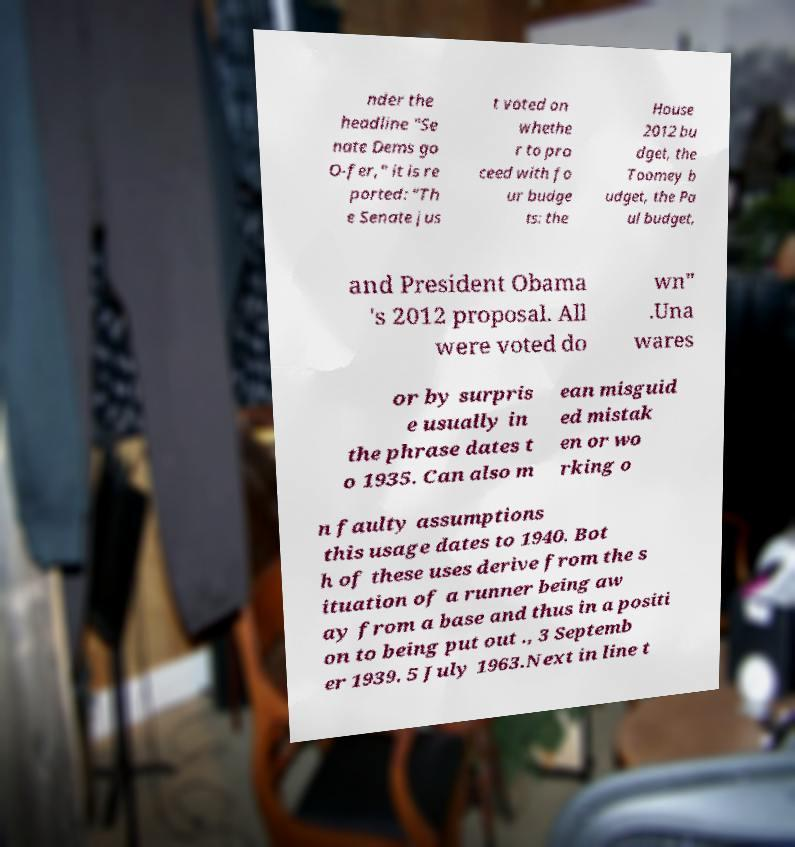Could you extract and type out the text from this image? nder the headline "Se nate Dems go O-fer," it is re ported: "Th e Senate jus t voted on whethe r to pro ceed with fo ur budge ts: the House 2012 bu dget, the Toomey b udget, the Pa ul budget, and President Obama 's 2012 proposal. All were voted do wn" .Una wares or by surpris e usually in the phrase dates t o 1935. Can also m ean misguid ed mistak en or wo rking o n faulty assumptions this usage dates to 1940. Bot h of these uses derive from the s ituation of a runner being aw ay from a base and thus in a positi on to being put out ., 3 Septemb er 1939. 5 July 1963.Next in line t 